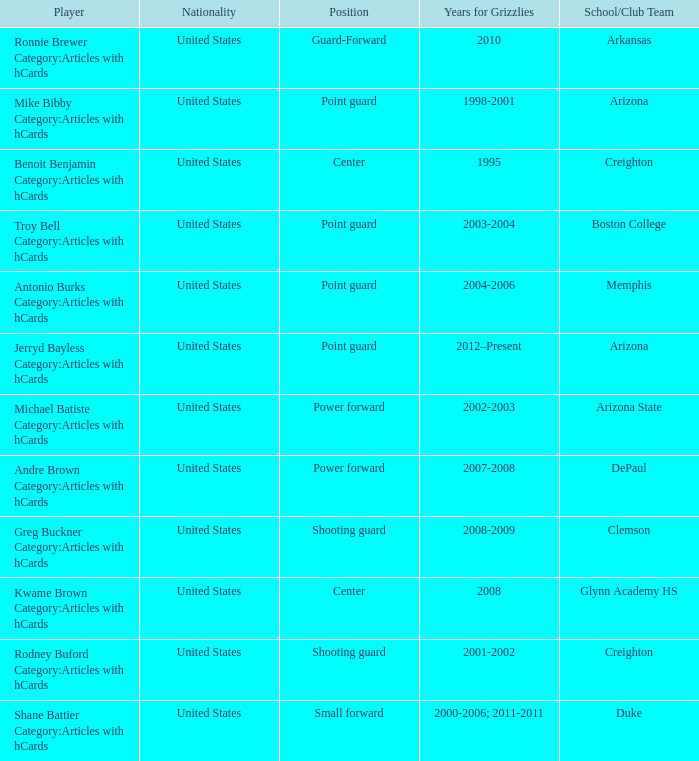Which Player has Years for Grizzlies of 2002-2003? Michael Batiste Category:Articles with hCards. 